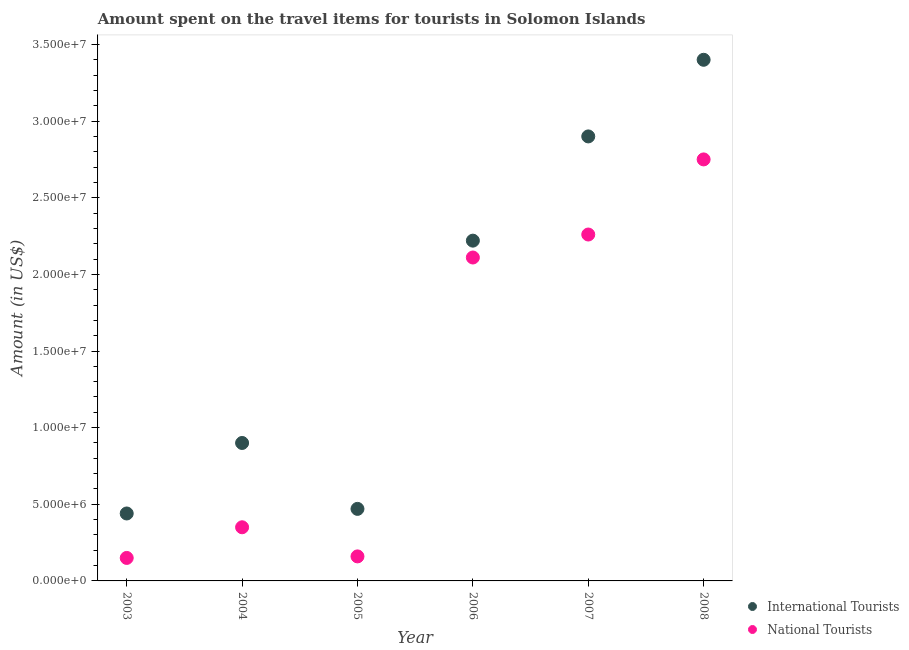What is the amount spent on travel items of national tourists in 2003?
Your answer should be very brief. 1.50e+06. Across all years, what is the maximum amount spent on travel items of international tourists?
Offer a very short reply. 3.40e+07. Across all years, what is the minimum amount spent on travel items of international tourists?
Offer a terse response. 4.40e+06. What is the total amount spent on travel items of national tourists in the graph?
Offer a terse response. 7.78e+07. What is the difference between the amount spent on travel items of international tourists in 2007 and that in 2008?
Keep it short and to the point. -5.00e+06. What is the difference between the amount spent on travel items of international tourists in 2003 and the amount spent on travel items of national tourists in 2005?
Provide a short and direct response. 2.80e+06. What is the average amount spent on travel items of national tourists per year?
Offer a terse response. 1.30e+07. In the year 2006, what is the difference between the amount spent on travel items of national tourists and amount spent on travel items of international tourists?
Your answer should be very brief. -1.10e+06. In how many years, is the amount spent on travel items of international tourists greater than 31000000 US$?
Your answer should be compact. 1. What is the ratio of the amount spent on travel items of national tourists in 2006 to that in 2008?
Keep it short and to the point. 0.77. Is the difference between the amount spent on travel items of international tourists in 2005 and 2007 greater than the difference between the amount spent on travel items of national tourists in 2005 and 2007?
Your answer should be compact. No. What is the difference between the highest and the second highest amount spent on travel items of national tourists?
Offer a terse response. 4.90e+06. What is the difference between the highest and the lowest amount spent on travel items of international tourists?
Keep it short and to the point. 2.96e+07. Is the sum of the amount spent on travel items of national tourists in 2006 and 2007 greater than the maximum amount spent on travel items of international tourists across all years?
Give a very brief answer. Yes. Does the amount spent on travel items of international tourists monotonically increase over the years?
Your answer should be very brief. No. Is the amount spent on travel items of national tourists strictly greater than the amount spent on travel items of international tourists over the years?
Ensure brevity in your answer.  No. How many dotlines are there?
Your response must be concise. 2. How many years are there in the graph?
Your answer should be very brief. 6. Are the values on the major ticks of Y-axis written in scientific E-notation?
Offer a very short reply. Yes. Does the graph contain any zero values?
Keep it short and to the point. No. Where does the legend appear in the graph?
Provide a succinct answer. Bottom right. How many legend labels are there?
Provide a succinct answer. 2. What is the title of the graph?
Make the answer very short. Amount spent on the travel items for tourists in Solomon Islands. Does "current US$" appear as one of the legend labels in the graph?
Your response must be concise. No. What is the label or title of the X-axis?
Offer a very short reply. Year. What is the label or title of the Y-axis?
Your answer should be very brief. Amount (in US$). What is the Amount (in US$) in International Tourists in 2003?
Make the answer very short. 4.40e+06. What is the Amount (in US$) in National Tourists in 2003?
Your answer should be very brief. 1.50e+06. What is the Amount (in US$) in International Tourists in 2004?
Keep it short and to the point. 9.00e+06. What is the Amount (in US$) in National Tourists in 2004?
Provide a short and direct response. 3.50e+06. What is the Amount (in US$) of International Tourists in 2005?
Offer a terse response. 4.70e+06. What is the Amount (in US$) in National Tourists in 2005?
Keep it short and to the point. 1.60e+06. What is the Amount (in US$) in International Tourists in 2006?
Your answer should be very brief. 2.22e+07. What is the Amount (in US$) of National Tourists in 2006?
Offer a terse response. 2.11e+07. What is the Amount (in US$) in International Tourists in 2007?
Offer a terse response. 2.90e+07. What is the Amount (in US$) of National Tourists in 2007?
Your answer should be compact. 2.26e+07. What is the Amount (in US$) of International Tourists in 2008?
Your answer should be very brief. 3.40e+07. What is the Amount (in US$) of National Tourists in 2008?
Ensure brevity in your answer.  2.75e+07. Across all years, what is the maximum Amount (in US$) of International Tourists?
Give a very brief answer. 3.40e+07. Across all years, what is the maximum Amount (in US$) of National Tourists?
Ensure brevity in your answer.  2.75e+07. Across all years, what is the minimum Amount (in US$) in International Tourists?
Your answer should be very brief. 4.40e+06. Across all years, what is the minimum Amount (in US$) in National Tourists?
Provide a short and direct response. 1.50e+06. What is the total Amount (in US$) of International Tourists in the graph?
Your answer should be compact. 1.03e+08. What is the total Amount (in US$) in National Tourists in the graph?
Ensure brevity in your answer.  7.78e+07. What is the difference between the Amount (in US$) of International Tourists in 2003 and that in 2004?
Offer a terse response. -4.60e+06. What is the difference between the Amount (in US$) in National Tourists in 2003 and that in 2004?
Offer a very short reply. -2.00e+06. What is the difference between the Amount (in US$) of National Tourists in 2003 and that in 2005?
Offer a terse response. -1.00e+05. What is the difference between the Amount (in US$) in International Tourists in 2003 and that in 2006?
Offer a terse response. -1.78e+07. What is the difference between the Amount (in US$) of National Tourists in 2003 and that in 2006?
Offer a very short reply. -1.96e+07. What is the difference between the Amount (in US$) of International Tourists in 2003 and that in 2007?
Your response must be concise. -2.46e+07. What is the difference between the Amount (in US$) in National Tourists in 2003 and that in 2007?
Offer a terse response. -2.11e+07. What is the difference between the Amount (in US$) in International Tourists in 2003 and that in 2008?
Provide a short and direct response. -2.96e+07. What is the difference between the Amount (in US$) in National Tourists in 2003 and that in 2008?
Your answer should be compact. -2.60e+07. What is the difference between the Amount (in US$) of International Tourists in 2004 and that in 2005?
Offer a very short reply. 4.30e+06. What is the difference between the Amount (in US$) in National Tourists in 2004 and that in 2005?
Your response must be concise. 1.90e+06. What is the difference between the Amount (in US$) in International Tourists in 2004 and that in 2006?
Provide a short and direct response. -1.32e+07. What is the difference between the Amount (in US$) of National Tourists in 2004 and that in 2006?
Give a very brief answer. -1.76e+07. What is the difference between the Amount (in US$) in International Tourists in 2004 and that in 2007?
Your answer should be compact. -2.00e+07. What is the difference between the Amount (in US$) in National Tourists in 2004 and that in 2007?
Your response must be concise. -1.91e+07. What is the difference between the Amount (in US$) in International Tourists in 2004 and that in 2008?
Offer a terse response. -2.50e+07. What is the difference between the Amount (in US$) in National Tourists in 2004 and that in 2008?
Offer a very short reply. -2.40e+07. What is the difference between the Amount (in US$) in International Tourists in 2005 and that in 2006?
Offer a very short reply. -1.75e+07. What is the difference between the Amount (in US$) in National Tourists in 2005 and that in 2006?
Give a very brief answer. -1.95e+07. What is the difference between the Amount (in US$) of International Tourists in 2005 and that in 2007?
Provide a short and direct response. -2.43e+07. What is the difference between the Amount (in US$) of National Tourists in 2005 and that in 2007?
Provide a short and direct response. -2.10e+07. What is the difference between the Amount (in US$) in International Tourists in 2005 and that in 2008?
Your response must be concise. -2.93e+07. What is the difference between the Amount (in US$) in National Tourists in 2005 and that in 2008?
Give a very brief answer. -2.59e+07. What is the difference between the Amount (in US$) in International Tourists in 2006 and that in 2007?
Provide a short and direct response. -6.80e+06. What is the difference between the Amount (in US$) of National Tourists in 2006 and that in 2007?
Offer a terse response. -1.50e+06. What is the difference between the Amount (in US$) of International Tourists in 2006 and that in 2008?
Make the answer very short. -1.18e+07. What is the difference between the Amount (in US$) in National Tourists in 2006 and that in 2008?
Your answer should be compact. -6.40e+06. What is the difference between the Amount (in US$) of International Tourists in 2007 and that in 2008?
Keep it short and to the point. -5.00e+06. What is the difference between the Amount (in US$) in National Tourists in 2007 and that in 2008?
Provide a succinct answer. -4.90e+06. What is the difference between the Amount (in US$) in International Tourists in 2003 and the Amount (in US$) in National Tourists in 2004?
Ensure brevity in your answer.  9.00e+05. What is the difference between the Amount (in US$) of International Tourists in 2003 and the Amount (in US$) of National Tourists in 2005?
Give a very brief answer. 2.80e+06. What is the difference between the Amount (in US$) of International Tourists in 2003 and the Amount (in US$) of National Tourists in 2006?
Your response must be concise. -1.67e+07. What is the difference between the Amount (in US$) in International Tourists in 2003 and the Amount (in US$) in National Tourists in 2007?
Make the answer very short. -1.82e+07. What is the difference between the Amount (in US$) of International Tourists in 2003 and the Amount (in US$) of National Tourists in 2008?
Offer a terse response. -2.31e+07. What is the difference between the Amount (in US$) of International Tourists in 2004 and the Amount (in US$) of National Tourists in 2005?
Your response must be concise. 7.40e+06. What is the difference between the Amount (in US$) of International Tourists in 2004 and the Amount (in US$) of National Tourists in 2006?
Keep it short and to the point. -1.21e+07. What is the difference between the Amount (in US$) in International Tourists in 2004 and the Amount (in US$) in National Tourists in 2007?
Ensure brevity in your answer.  -1.36e+07. What is the difference between the Amount (in US$) of International Tourists in 2004 and the Amount (in US$) of National Tourists in 2008?
Your answer should be very brief. -1.85e+07. What is the difference between the Amount (in US$) of International Tourists in 2005 and the Amount (in US$) of National Tourists in 2006?
Offer a terse response. -1.64e+07. What is the difference between the Amount (in US$) of International Tourists in 2005 and the Amount (in US$) of National Tourists in 2007?
Give a very brief answer. -1.79e+07. What is the difference between the Amount (in US$) of International Tourists in 2005 and the Amount (in US$) of National Tourists in 2008?
Provide a short and direct response. -2.28e+07. What is the difference between the Amount (in US$) of International Tourists in 2006 and the Amount (in US$) of National Tourists in 2007?
Provide a succinct answer. -4.00e+05. What is the difference between the Amount (in US$) in International Tourists in 2006 and the Amount (in US$) in National Tourists in 2008?
Your response must be concise. -5.30e+06. What is the difference between the Amount (in US$) in International Tourists in 2007 and the Amount (in US$) in National Tourists in 2008?
Your response must be concise. 1.50e+06. What is the average Amount (in US$) in International Tourists per year?
Your answer should be very brief. 1.72e+07. What is the average Amount (in US$) of National Tourists per year?
Provide a short and direct response. 1.30e+07. In the year 2003, what is the difference between the Amount (in US$) in International Tourists and Amount (in US$) in National Tourists?
Provide a short and direct response. 2.90e+06. In the year 2004, what is the difference between the Amount (in US$) of International Tourists and Amount (in US$) of National Tourists?
Ensure brevity in your answer.  5.50e+06. In the year 2005, what is the difference between the Amount (in US$) of International Tourists and Amount (in US$) of National Tourists?
Keep it short and to the point. 3.10e+06. In the year 2006, what is the difference between the Amount (in US$) of International Tourists and Amount (in US$) of National Tourists?
Your answer should be very brief. 1.10e+06. In the year 2007, what is the difference between the Amount (in US$) of International Tourists and Amount (in US$) of National Tourists?
Make the answer very short. 6.40e+06. In the year 2008, what is the difference between the Amount (in US$) in International Tourists and Amount (in US$) in National Tourists?
Ensure brevity in your answer.  6.50e+06. What is the ratio of the Amount (in US$) of International Tourists in 2003 to that in 2004?
Provide a short and direct response. 0.49. What is the ratio of the Amount (in US$) of National Tourists in 2003 to that in 2004?
Offer a terse response. 0.43. What is the ratio of the Amount (in US$) in International Tourists in 2003 to that in 2005?
Provide a succinct answer. 0.94. What is the ratio of the Amount (in US$) in International Tourists in 2003 to that in 2006?
Offer a terse response. 0.2. What is the ratio of the Amount (in US$) in National Tourists in 2003 to that in 2006?
Offer a terse response. 0.07. What is the ratio of the Amount (in US$) in International Tourists in 2003 to that in 2007?
Offer a very short reply. 0.15. What is the ratio of the Amount (in US$) in National Tourists in 2003 to that in 2007?
Give a very brief answer. 0.07. What is the ratio of the Amount (in US$) of International Tourists in 2003 to that in 2008?
Your answer should be very brief. 0.13. What is the ratio of the Amount (in US$) in National Tourists in 2003 to that in 2008?
Ensure brevity in your answer.  0.05. What is the ratio of the Amount (in US$) of International Tourists in 2004 to that in 2005?
Your response must be concise. 1.91. What is the ratio of the Amount (in US$) in National Tourists in 2004 to that in 2005?
Offer a very short reply. 2.19. What is the ratio of the Amount (in US$) of International Tourists in 2004 to that in 2006?
Offer a terse response. 0.41. What is the ratio of the Amount (in US$) in National Tourists in 2004 to that in 2006?
Your answer should be very brief. 0.17. What is the ratio of the Amount (in US$) in International Tourists in 2004 to that in 2007?
Offer a terse response. 0.31. What is the ratio of the Amount (in US$) in National Tourists in 2004 to that in 2007?
Make the answer very short. 0.15. What is the ratio of the Amount (in US$) in International Tourists in 2004 to that in 2008?
Your answer should be very brief. 0.26. What is the ratio of the Amount (in US$) of National Tourists in 2004 to that in 2008?
Provide a short and direct response. 0.13. What is the ratio of the Amount (in US$) of International Tourists in 2005 to that in 2006?
Give a very brief answer. 0.21. What is the ratio of the Amount (in US$) of National Tourists in 2005 to that in 2006?
Provide a succinct answer. 0.08. What is the ratio of the Amount (in US$) in International Tourists in 2005 to that in 2007?
Your answer should be very brief. 0.16. What is the ratio of the Amount (in US$) in National Tourists in 2005 to that in 2007?
Ensure brevity in your answer.  0.07. What is the ratio of the Amount (in US$) of International Tourists in 2005 to that in 2008?
Offer a very short reply. 0.14. What is the ratio of the Amount (in US$) in National Tourists in 2005 to that in 2008?
Offer a very short reply. 0.06. What is the ratio of the Amount (in US$) of International Tourists in 2006 to that in 2007?
Your answer should be very brief. 0.77. What is the ratio of the Amount (in US$) in National Tourists in 2006 to that in 2007?
Keep it short and to the point. 0.93. What is the ratio of the Amount (in US$) in International Tourists in 2006 to that in 2008?
Make the answer very short. 0.65. What is the ratio of the Amount (in US$) of National Tourists in 2006 to that in 2008?
Provide a short and direct response. 0.77. What is the ratio of the Amount (in US$) in International Tourists in 2007 to that in 2008?
Your answer should be compact. 0.85. What is the ratio of the Amount (in US$) in National Tourists in 2007 to that in 2008?
Give a very brief answer. 0.82. What is the difference between the highest and the second highest Amount (in US$) in International Tourists?
Your answer should be compact. 5.00e+06. What is the difference between the highest and the second highest Amount (in US$) of National Tourists?
Provide a succinct answer. 4.90e+06. What is the difference between the highest and the lowest Amount (in US$) of International Tourists?
Your answer should be compact. 2.96e+07. What is the difference between the highest and the lowest Amount (in US$) in National Tourists?
Ensure brevity in your answer.  2.60e+07. 